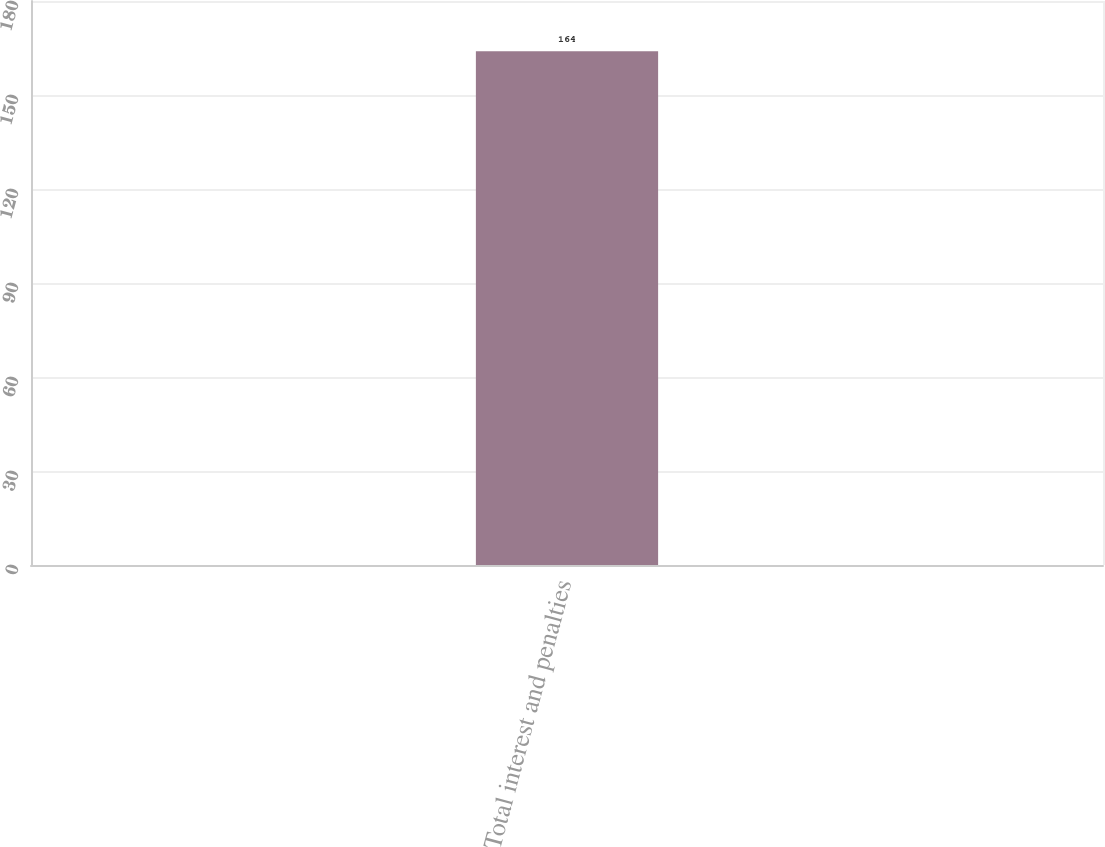Convert chart to OTSL. <chart><loc_0><loc_0><loc_500><loc_500><bar_chart><fcel>Total interest and penalties<nl><fcel>164<nl></chart> 